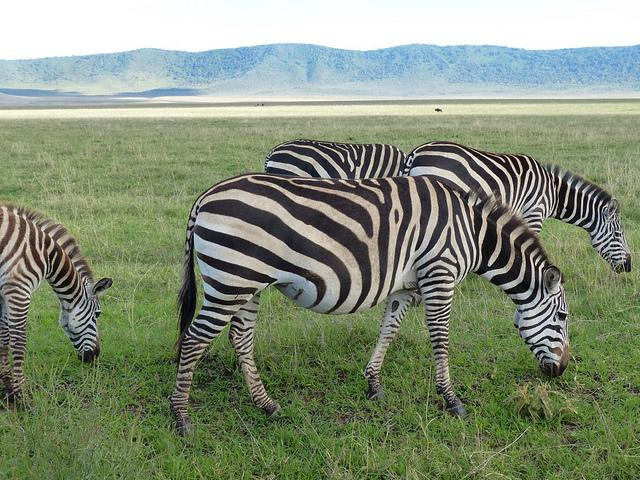What are the zebras doing?

Choices:
A) grazing
B) mating
C) sleeping
D) fighting grazing 